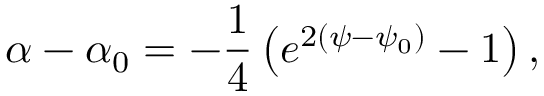<formula> <loc_0><loc_0><loc_500><loc_500>\alpha - \alpha _ { 0 } = - \frac { 1 } { 4 } \left ( e ^ { 2 ( \psi - \psi _ { 0 } ) } - 1 \right ) ,</formula> 